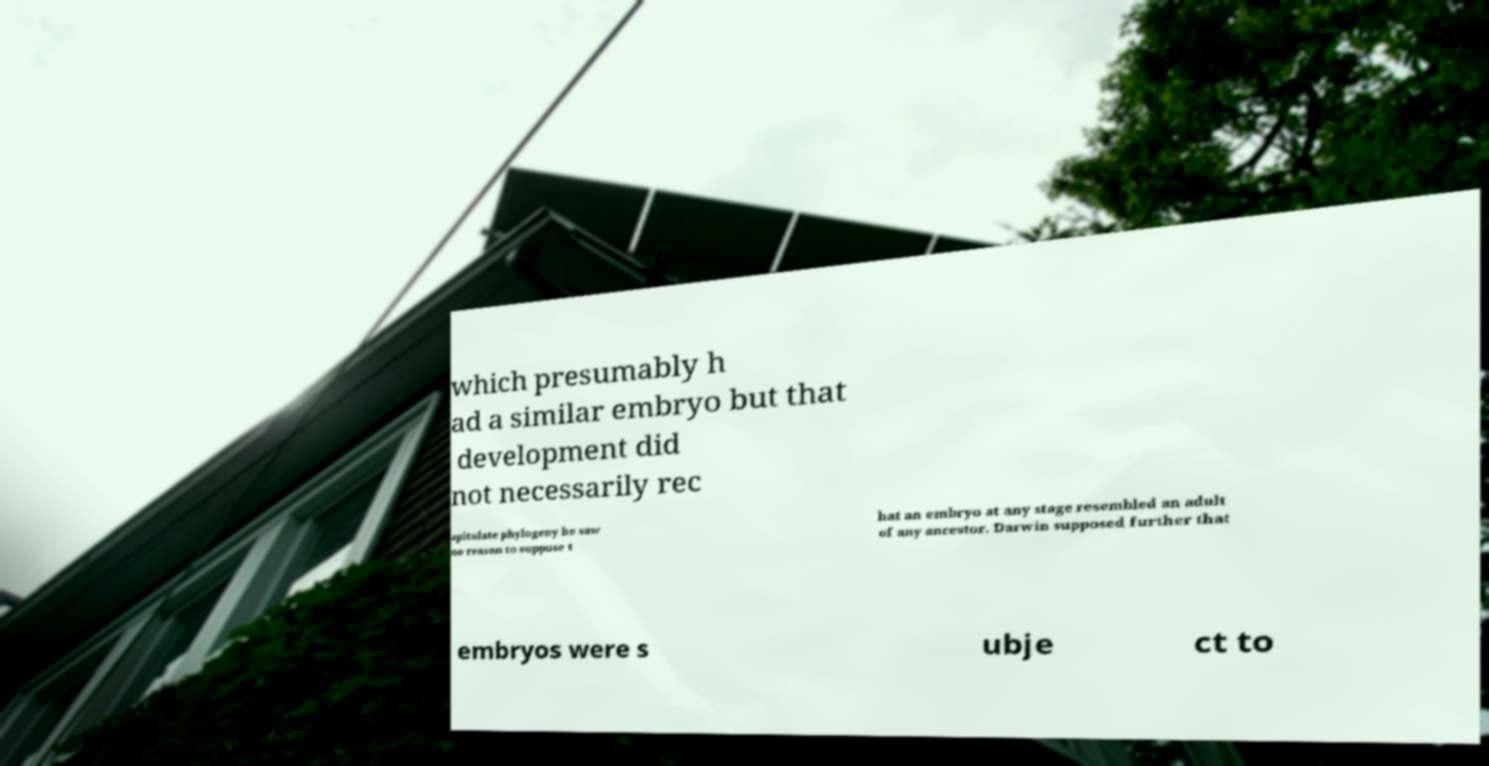Could you extract and type out the text from this image? which presumably h ad a similar embryo but that development did not necessarily rec apitulate phylogeny he saw no reason to suppose t hat an embryo at any stage resembled an adult of any ancestor. Darwin supposed further that embryos were s ubje ct to 